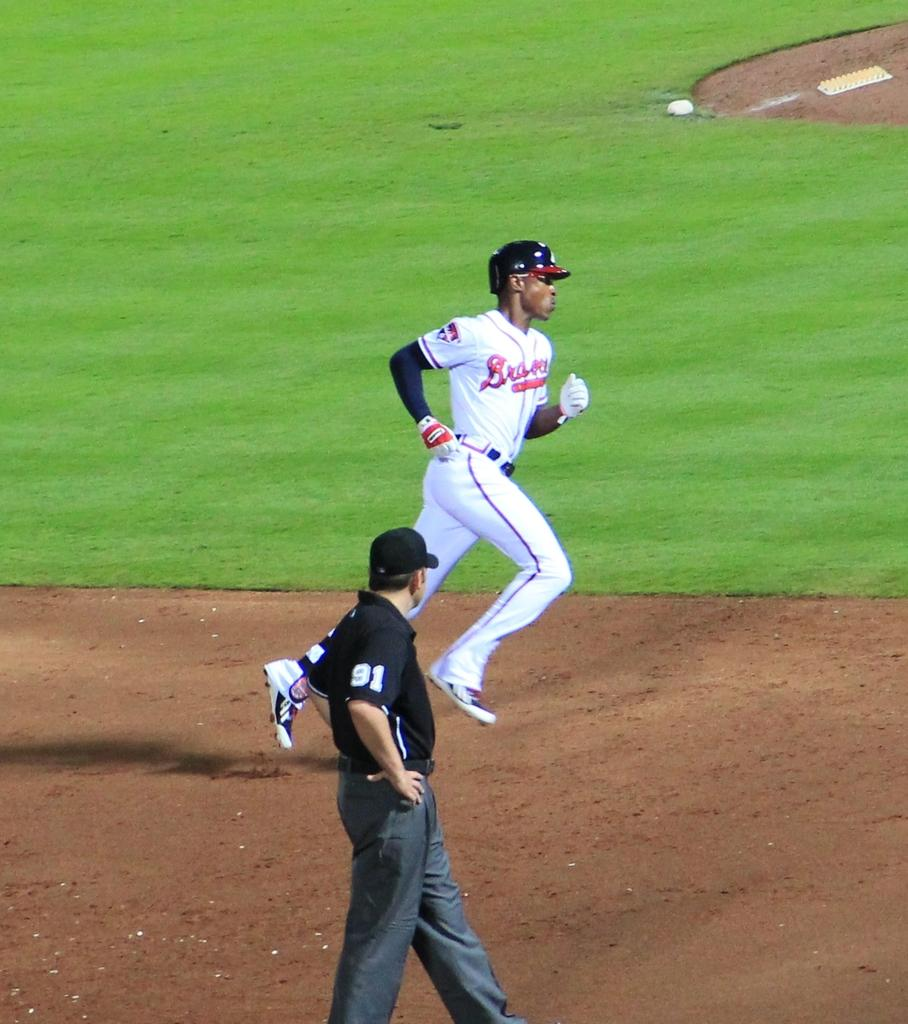<image>
Share a concise interpretation of the image provided. A baseball player is running by a referee who has number 91 on his shirt. 